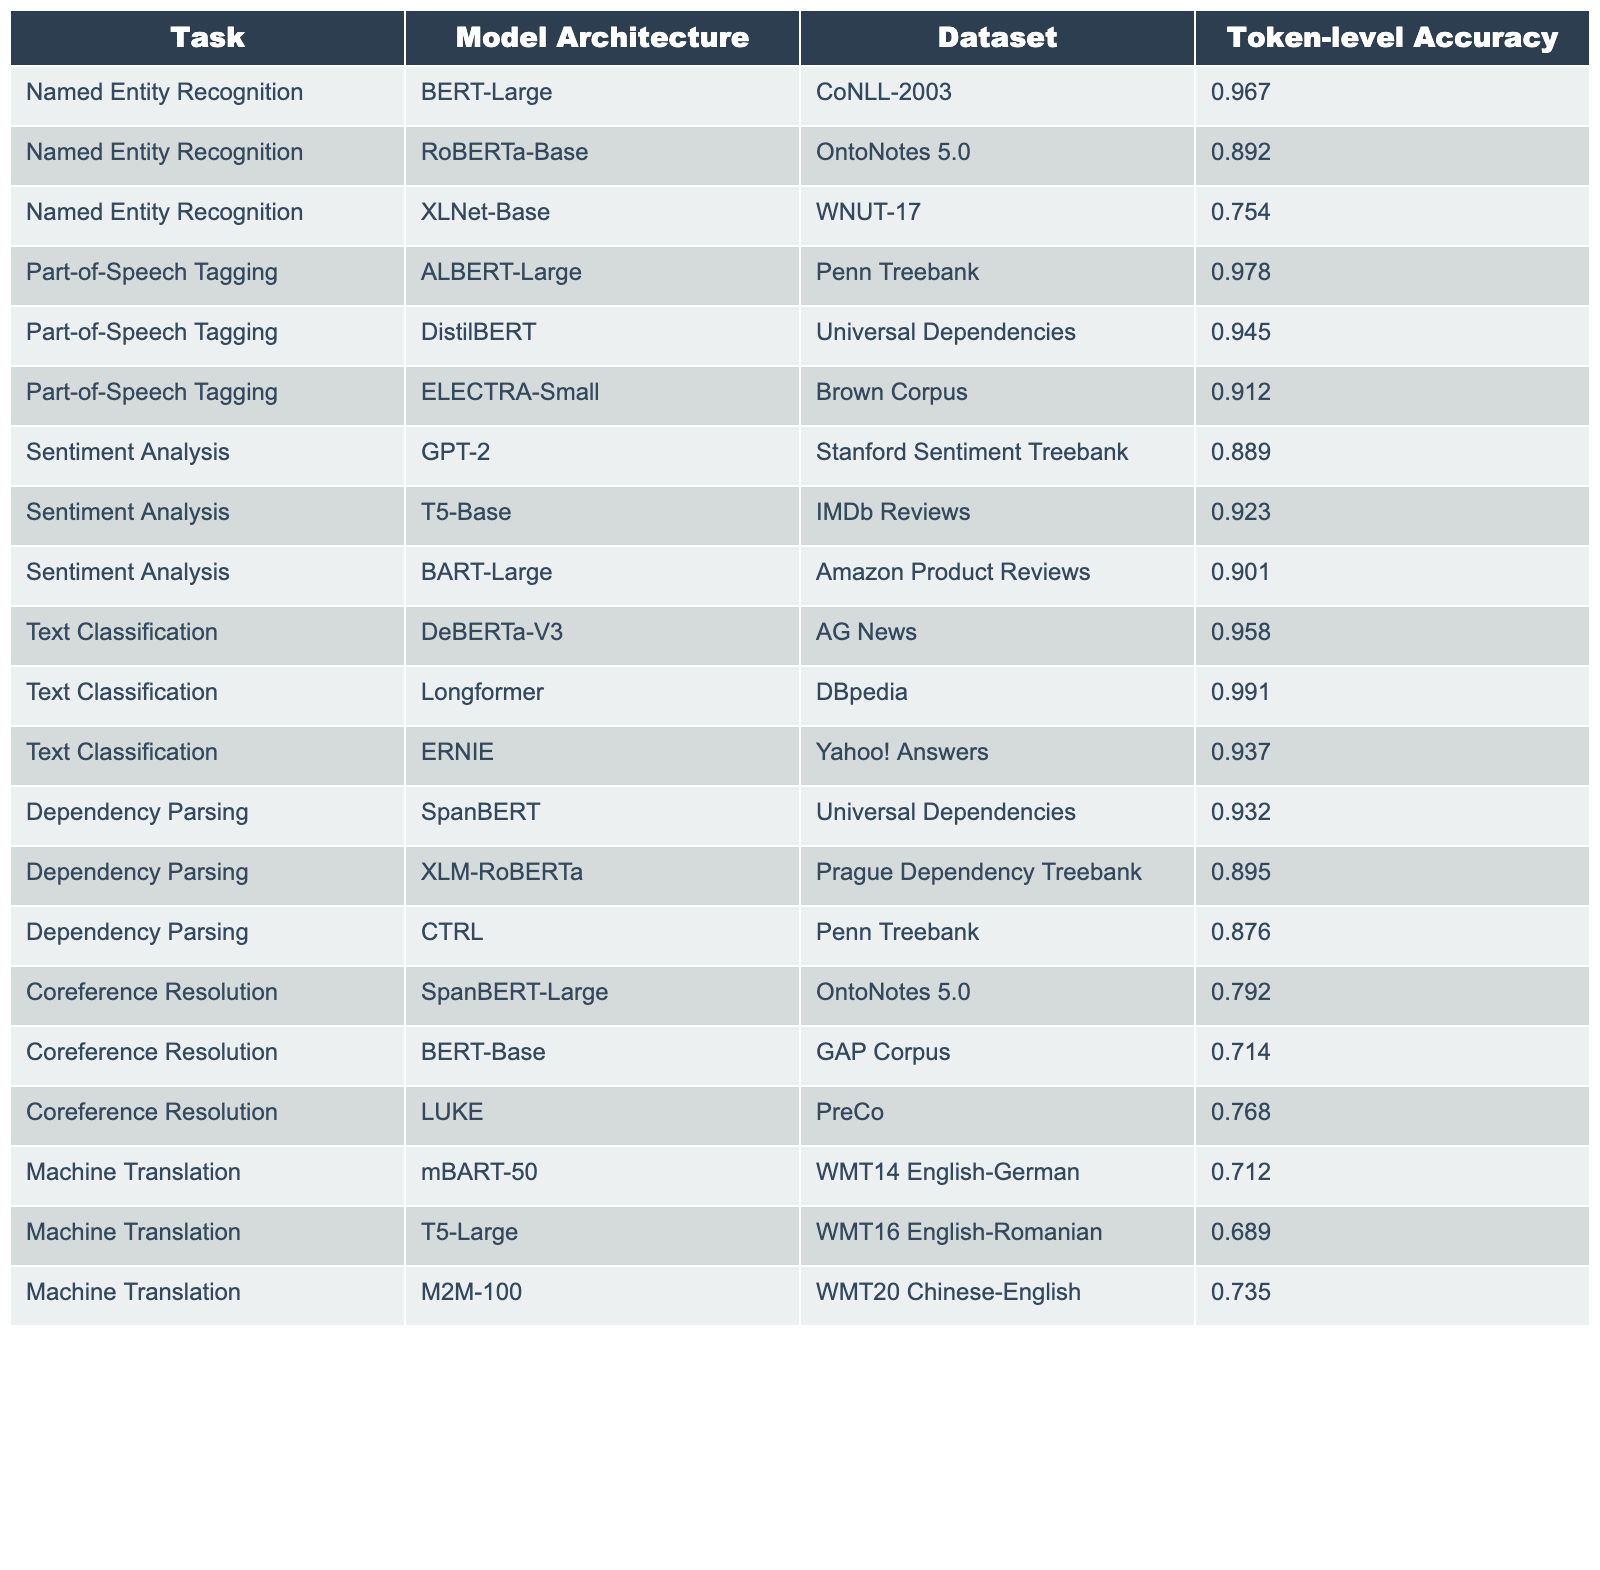What is the token-level accuracy of BERT-Large for Named Entity Recognition? According to the table, the token-level accuracy for BERT-Large in the Named Entity Recognition task is listed under the corresponding row. It shows a value of 0.967.
Answer: 0.967 Which model architecture achieved the highest token-level accuracy in Text Classification? The table details the token-level accuracies for various model architectures in Text Classification. Longformer has the highest accuracy at 0.991, as seen in the relevant row.
Answer: 0.991 Is the token-level accuracy of RoBERTa-Base higher than that of XLNet-Base in Named Entity Recognition? To determine this, we look at the accuracies of both models in the Named Entity Recognition task: RoBERTa-Base shows 0.892 and XLNet-Base shows 0.754, indicating that RoBERTa-Base is higher.
Answer: Yes What is the average token-level accuracy across all models for the Coreference Resolution task? The token-level accuracies for the Coreference Resolution task are 0.792, 0.714, and 0.768 for SpanBERT-Large, BERT-Base, and LUKE respectively. To find the average, we sum these values: (0.792 + 0.714 + 0.768) = 2.274, and then divide by 3, giving an average of 2.274 / 3 = 0.758.
Answer: 0.758 Which NLP task shows the lowest token-level accuracy among all the models listed? By examining the entire table, we should focus on the lowest accuracy values. The Machine Translation task has the lowest token-level accuracy of 0.689 for T5-Large, making it the task with the lowest performance.
Answer: 0.689 What is the difference in token-level accuracy between ALBERT-Large and ELECTRA-Small for Part-of-Speech Tagging? We look at the accuracies for ALBERT-Large (0.978) and ELECTRA-Small (0.912) under Part-of-Speech Tagging. The difference is calculated by subtracting these two values: 0.978 - 0.912 = 0.066.
Answer: 0.066 Which model has the highest token-level accuracy for Dependency Parsing? The table lists the token-level accuracies for Dependency Parsing, with SpanBERT having the highest accuracy of 0.932 compared to its peers.
Answer: 0.932 How many tasks have a token-level accuracy greater than 0.900? Analyzing each task in the table, we identify all accuracies greater than 0.900. Those tasks are Named Entity Recognition (BERT-Large), Part-of-Speech Tagging (ALBERT-Large and DistilBERT), Sentiment Analysis (T5-Base), Text Classification (DeBERTa-V3 and Longformer), and Dependency Parsing (SpanBERT). Counting these tasks gives us a total of 8 tasks with accuracies above 0.900.
Answer: 8 What is the token-level accuracy for the model architecture M2M-100 in the Machine Translation task? The token-level accuracy for M2M-100 in the Machine Translation task is found in the corresponding row of the table, which states a value of 0.735.
Answer: 0.735 Is the accuracy of SpanBERT for Coreference Resolution better than that of BERT-Base? Checking the table records, SpanBERT-Large has a token-level accuracy of 0.792 for Coreference Resolution, while BERT-Base has 0.714. Comparing these shows that SpanBERT-Large performs better.
Answer: Yes 